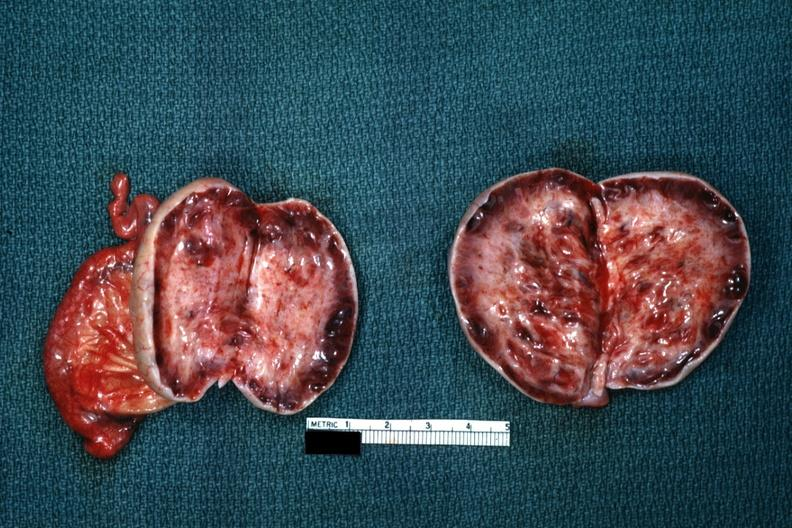what is present?
Answer the question using a single word or phrase. Ovary 